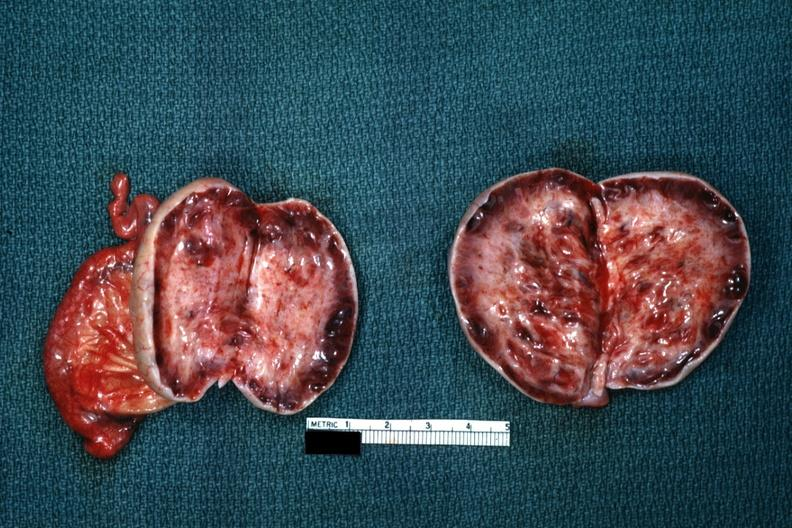what is present?
Answer the question using a single word or phrase. Ovary 